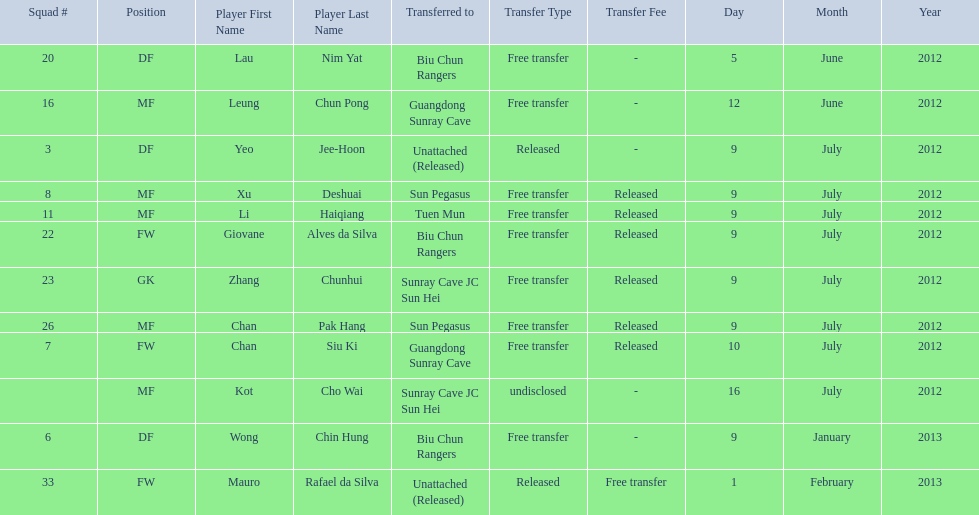On what dates were there non released free transfers? 5 June 2012, 12 June 2012, 9 January 2013, 1 February 2013. On which of these were the players transferred to another team? 5 June 2012, 12 June 2012, 9 January 2013. Which of these were the transfers to biu chun rangers? 5 June 2012, 9 January 2013. On which of those dated did they receive a df? 9 January 2013. 